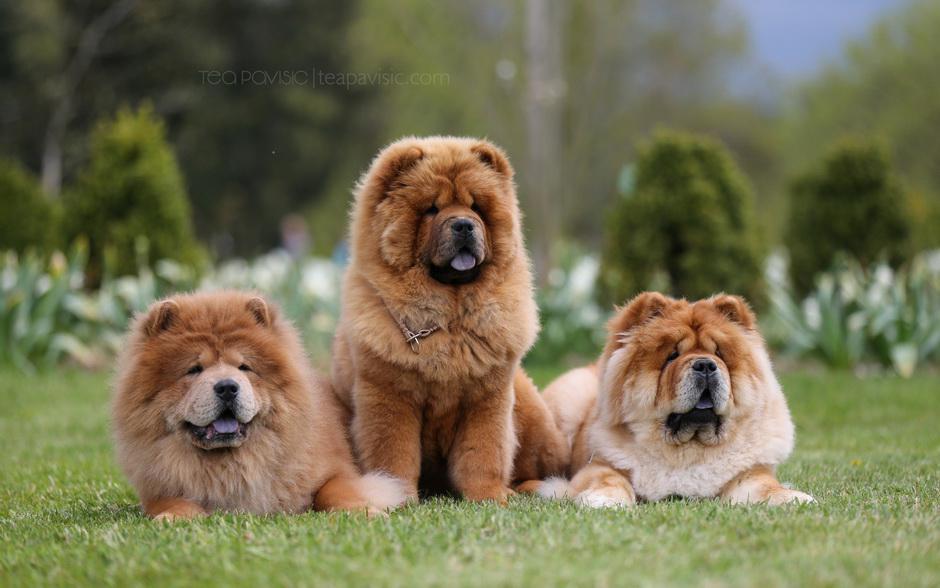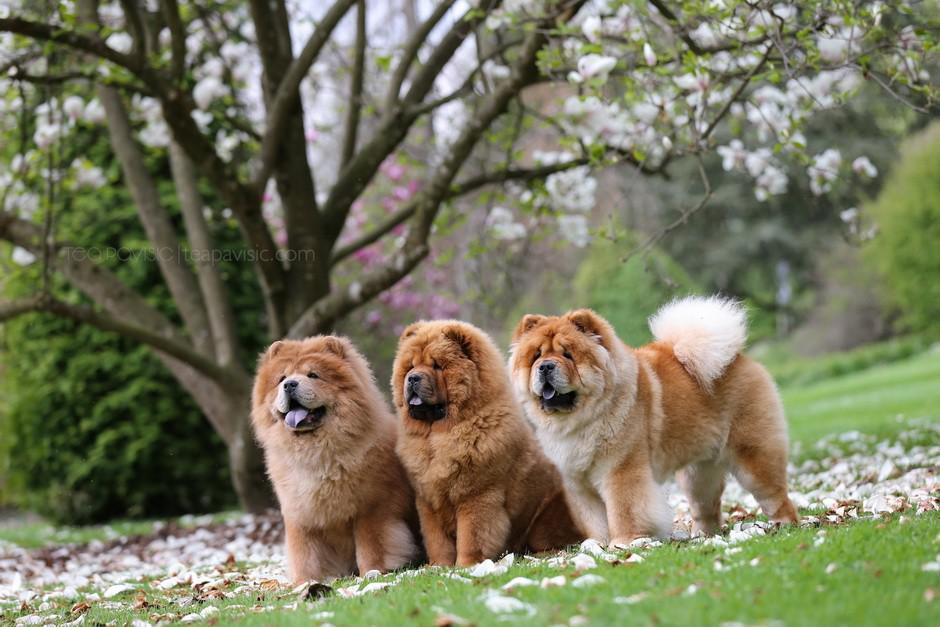The first image is the image on the left, the second image is the image on the right. For the images displayed, is the sentence "In one of the image the dog is laying on a bed." factually correct? Answer yes or no. No. The first image is the image on the left, the second image is the image on the right. Given the left and right images, does the statement "All Chow dogs are on the grass." hold true? Answer yes or no. Yes. 